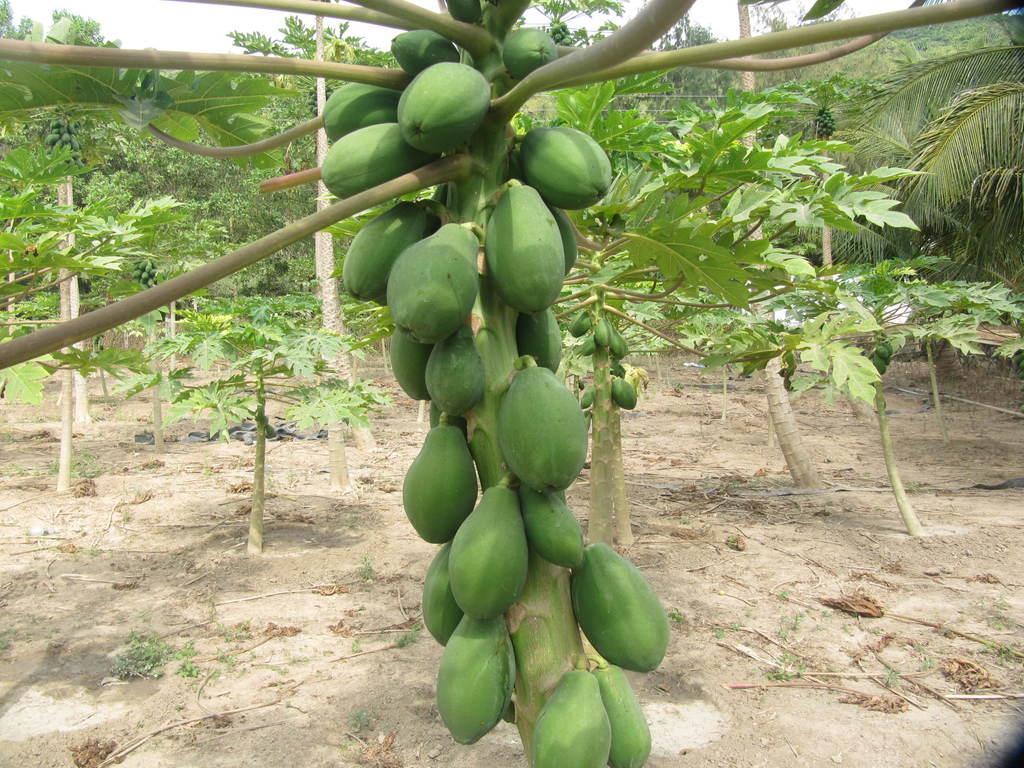Describe this image in one or two sentences. In the picture we can see some papaya trees with papaya which are green in color and we can also see some part of the sky. 